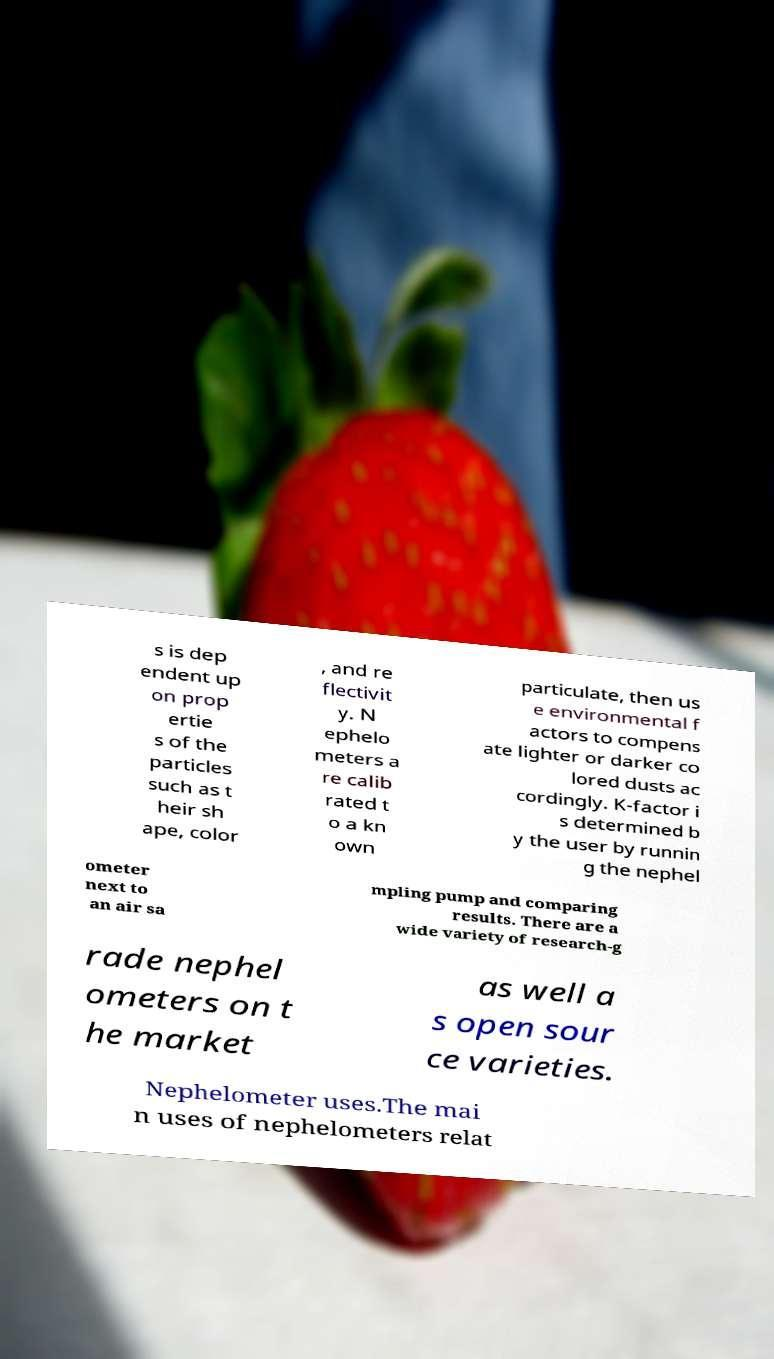I need the written content from this picture converted into text. Can you do that? s is dep endent up on prop ertie s of the particles such as t heir sh ape, color , and re flectivit y. N ephelo meters a re calib rated t o a kn own particulate, then us e environmental f actors to compens ate lighter or darker co lored dusts ac cordingly. K-factor i s determined b y the user by runnin g the nephel ometer next to an air sa mpling pump and comparing results. There are a wide variety of research-g rade nephel ometers on t he market as well a s open sour ce varieties. Nephelometer uses.The mai n uses of nephelometers relat 